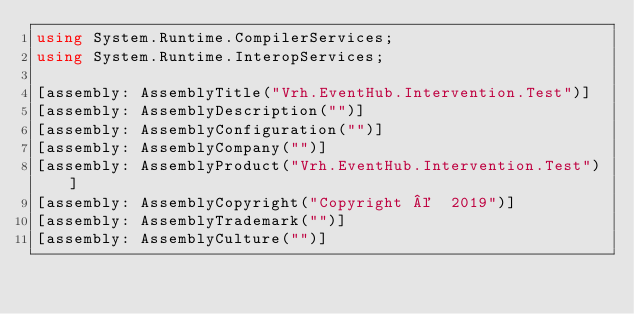<code> <loc_0><loc_0><loc_500><loc_500><_C#_>using System.Runtime.CompilerServices;
using System.Runtime.InteropServices;

[assembly: AssemblyTitle("Vrh.EventHub.Intervention.Test")]
[assembly: AssemblyDescription("")]
[assembly: AssemblyConfiguration("")]
[assembly: AssemblyCompany("")]
[assembly: AssemblyProduct("Vrh.EventHub.Intervention.Test")]
[assembly: AssemblyCopyright("Copyright ©  2019")]
[assembly: AssemblyTrademark("")]
[assembly: AssemblyCulture("")]
</code> 